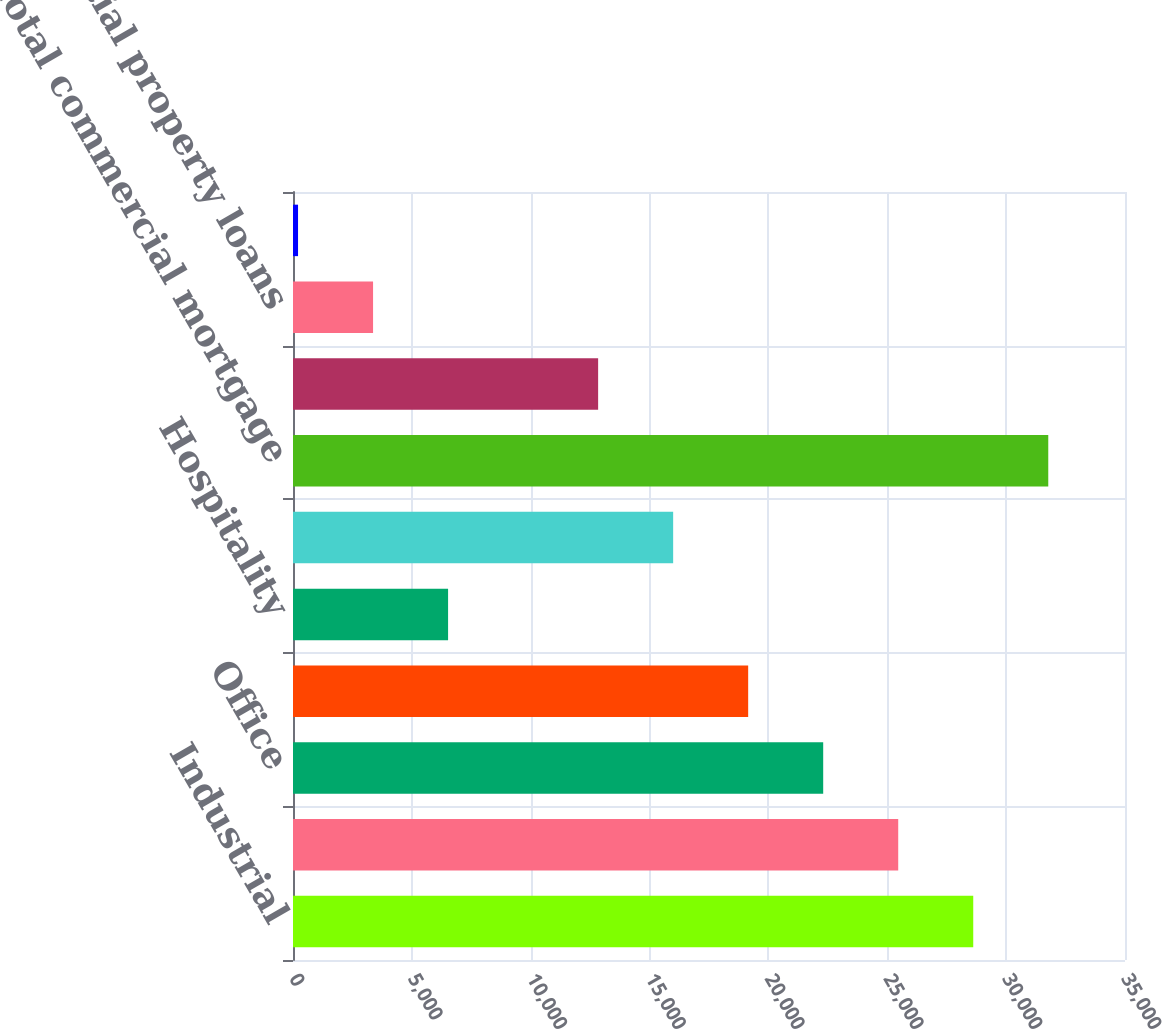Convert chart to OTSL. <chart><loc_0><loc_0><loc_500><loc_500><bar_chart><fcel>Industrial<fcel>Retail<fcel>Office<fcel>Multi-Family/Apartment<fcel>Hospitality<fcel>Other<fcel>Total commercial mortgage<fcel>Agricultural property loans<fcel>Residential property loans<fcel>Other collateralized loans<nl><fcel>28616<fcel>25460<fcel>22304<fcel>19148<fcel>6524<fcel>15992<fcel>31772<fcel>12836<fcel>3368<fcel>212<nl></chart> 